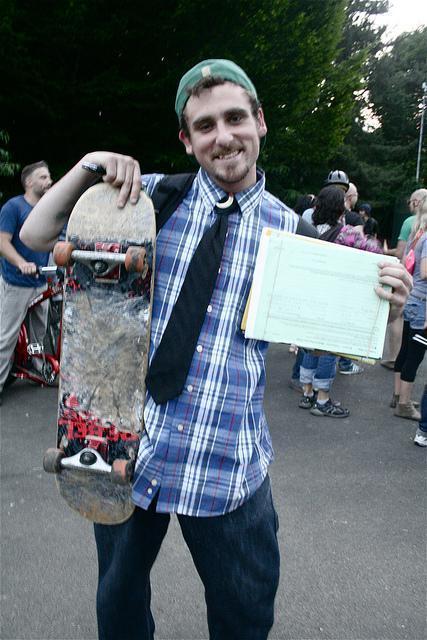How many people are there?
Give a very brief answer. 4. 